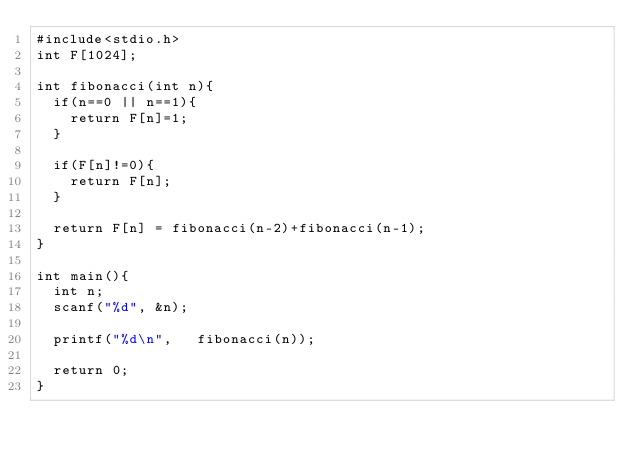Convert code to text. <code><loc_0><loc_0><loc_500><loc_500><_C_>#include<stdio.h>
int F[1024];

int fibonacci(int n){
  if(n==0 || n==1){
    return F[n]=1;
  }

  if(F[n]!=0){
    return F[n];
  }

  return F[n] = fibonacci(n-2)+fibonacci(n-1);
}

int main(){
  int n;
  scanf("%d", &n);

  printf("%d\n",   fibonacci(n));

  return 0;
}</code> 